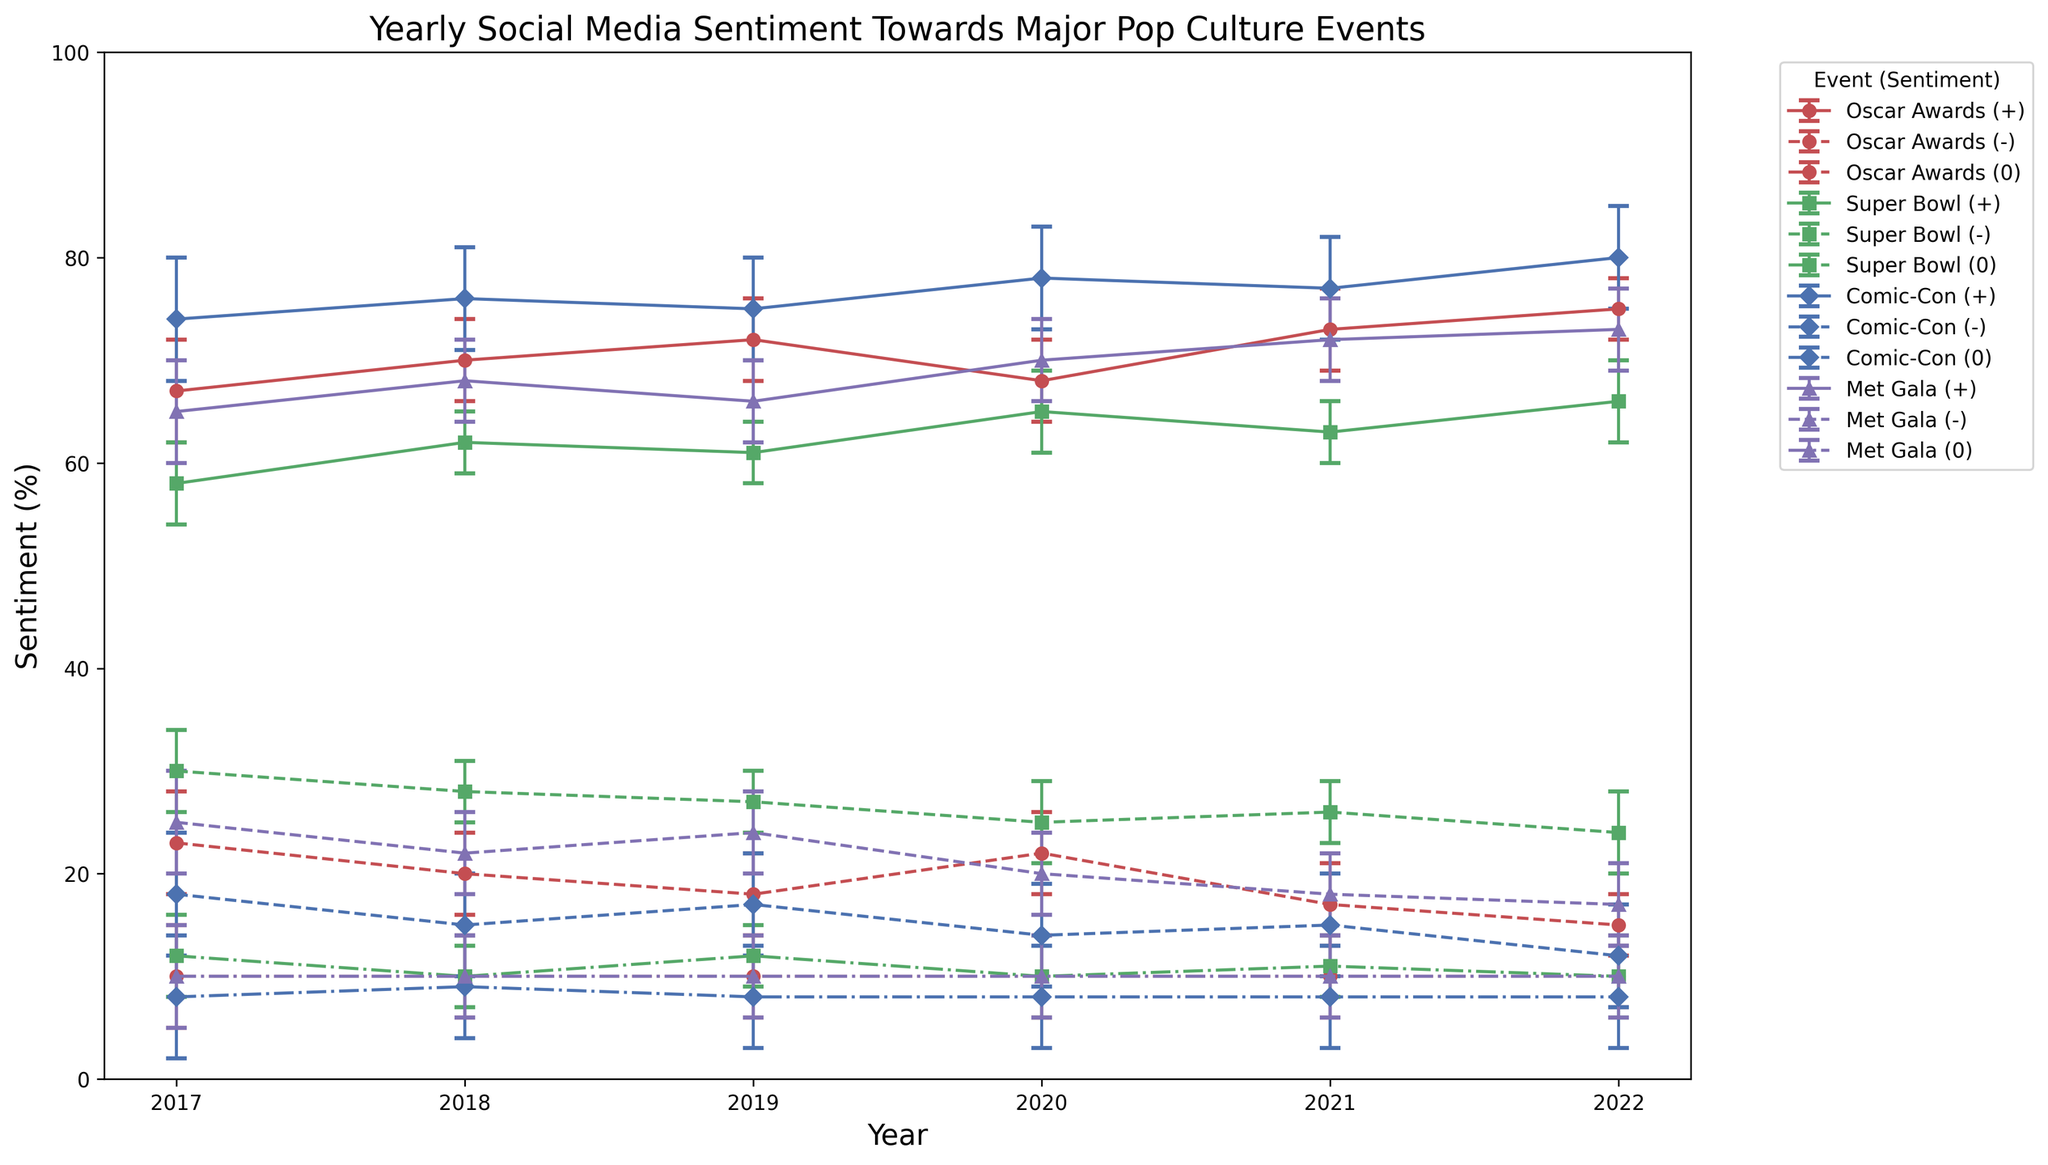What's the positive sentiment for the Comic-Con in 2022? Look for the Comic-Con data point for the year 2022 in the positive sentiment series. According to the data, the positive sentiment is shown on the chart with the "+" marker, colored in blue. Find the intersection of this marker for Comic-Con in 2022.
Answer: 80% Which event had the lowest negative sentiment in 2017? Look for the negative sentiment markers for the year 2017, each labeled with events, represented by distinct markers and color schemes. Find the lowest point among all negative sentiments. Comic-Con, depicted by a blue diamond with a dashed line, had the lowest negative sentiment.
Answer: Comic-Con What is the trend in positive sentiment for Oscar Awards from 2017 to 2022? Find and trace the line for Oscar Awards marked by a red circles with solid lines from 2017 to 2022 on the chart. The positive sentiment generally increases over this period.
Answer: Increasing What's the average positive sentiment for the Super Bowl from 2020 to 2022? Find the positive sentiment values for Super Bowl in 2020 (65), 2021 (63), and 2022 (66). Calculate the average: (65 + 63 + 66) / 3 = 64.67.
Answer: 64.67 Which event had the highest improvement in positive sentiment from 2017 to 2018? Compare the positive sentiment for each event in 2017 and 2018. Comic-Con had a positive sentiment increase from 74% in 2017 to 76% in 2018, which is the highest increase of 2%.
Answer: Comic-Con What is the highest neutral sentiment across all events in 2019? Look at all the neutral sentiment markers within the year 2019, which are indicated by markers and colors for each event's neutral data line. Each event marker should have a corresponding neutral sentiment line. The highest neutral sentiment for 2019 is from the Super Bowl at 12%.
Answer: Super Bowl Between the Met Gala and the Oscar Awards, which had a lower positive sentiment in 2020? Compare the positive sentiment values for the Met Gala and the Oscar Awards in the year 2020. Met Gala had 70%, and Oscar Awards had 68%. Since Met Gala has a higher positive sentiment, Oscar Awards had a lower positive sentiment.
Answer: Oscar Awards What’s the overall trend in negative sentiment for the Super Bowl from 2017 to 2022? Trace the negative sentiment markers for the Super Bowl over the period 2017 to 2022, represented with an "S" marker and dashed green lines. The negative sentiment remains relatively consistent with minor fluctuations. It peaked slightly in 2017 and 2019 and slightly decreased by 2022.
Answer: Relatively consistent Which event showed the largest confidence interval in any given year, and what year was that? Look at the confidence intervals represented with error bars attached to each sentiment data point. The largest bar is noticed at the Comic-Con in 2017, with a confidence interval of +/- 6%.
Answer: Comic-Con, 2017 